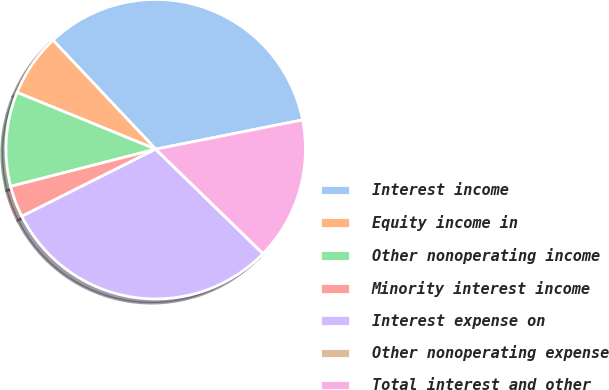<chart> <loc_0><loc_0><loc_500><loc_500><pie_chart><fcel>Interest income<fcel>Equity income in<fcel>Other nonoperating income<fcel>Minority interest income<fcel>Interest expense on<fcel>Other nonoperating expense<fcel>Total interest and other<nl><fcel>33.9%<fcel>6.79%<fcel>10.18%<fcel>3.4%<fcel>30.32%<fcel>0.01%<fcel>15.4%<nl></chart> 